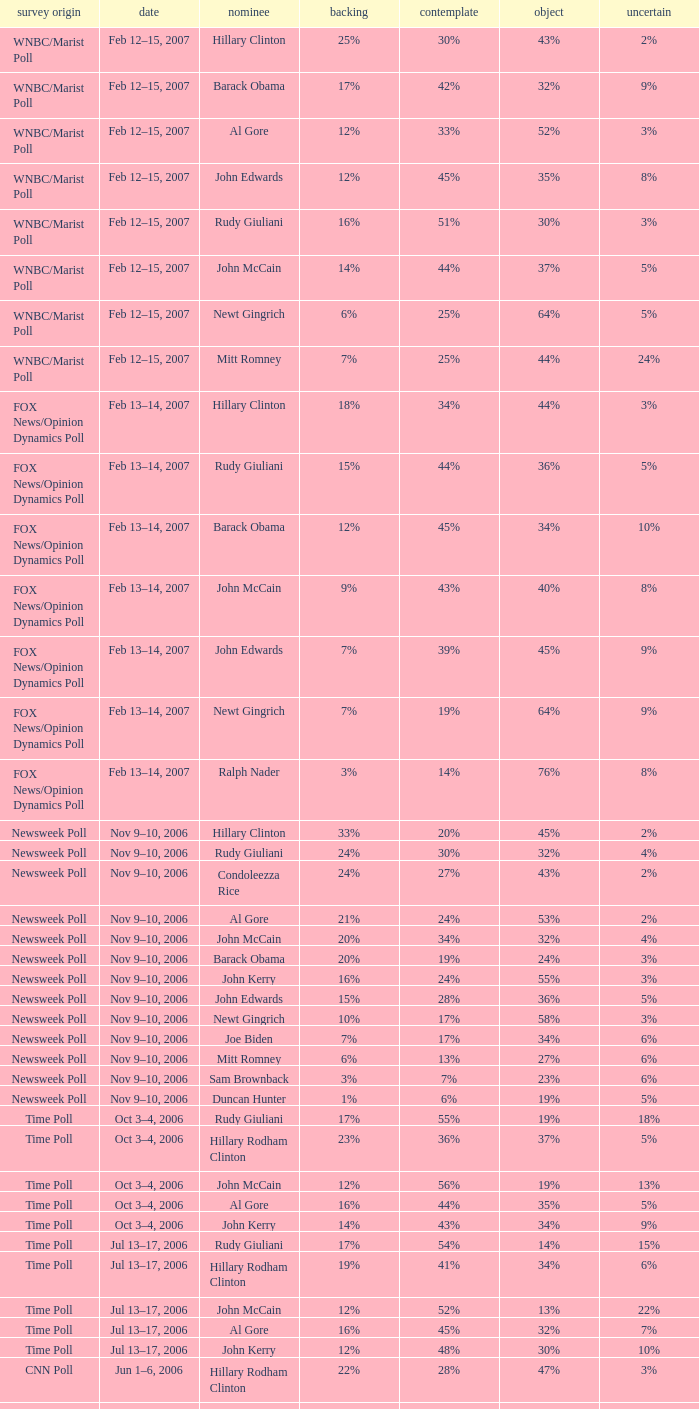What percentage of people were opposed to the candidate based on the WNBC/Marist poll that showed 8% of people were unsure? 35%. 